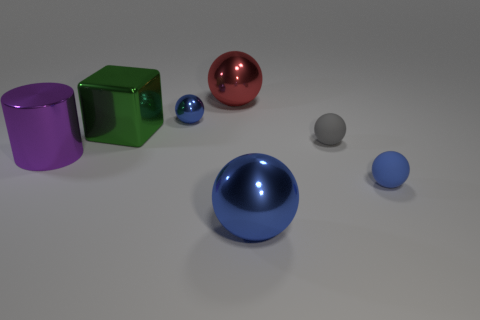What lighting conditions are present in the image? The image has a soft, diffused overhead lighting that casts gentle shadows beneath the objects, highlighting their shapes and textures without creating harsh reflections. Can you explain how shadows help in determining the shape of an object? Shadows can provide cues about an object's form and the space it occupies. The direction and length of a shadow can reveal the light source's angle, while the shadow's shape can mimic or accentuate the contour of the object, indicating its three-dimensional structure. 